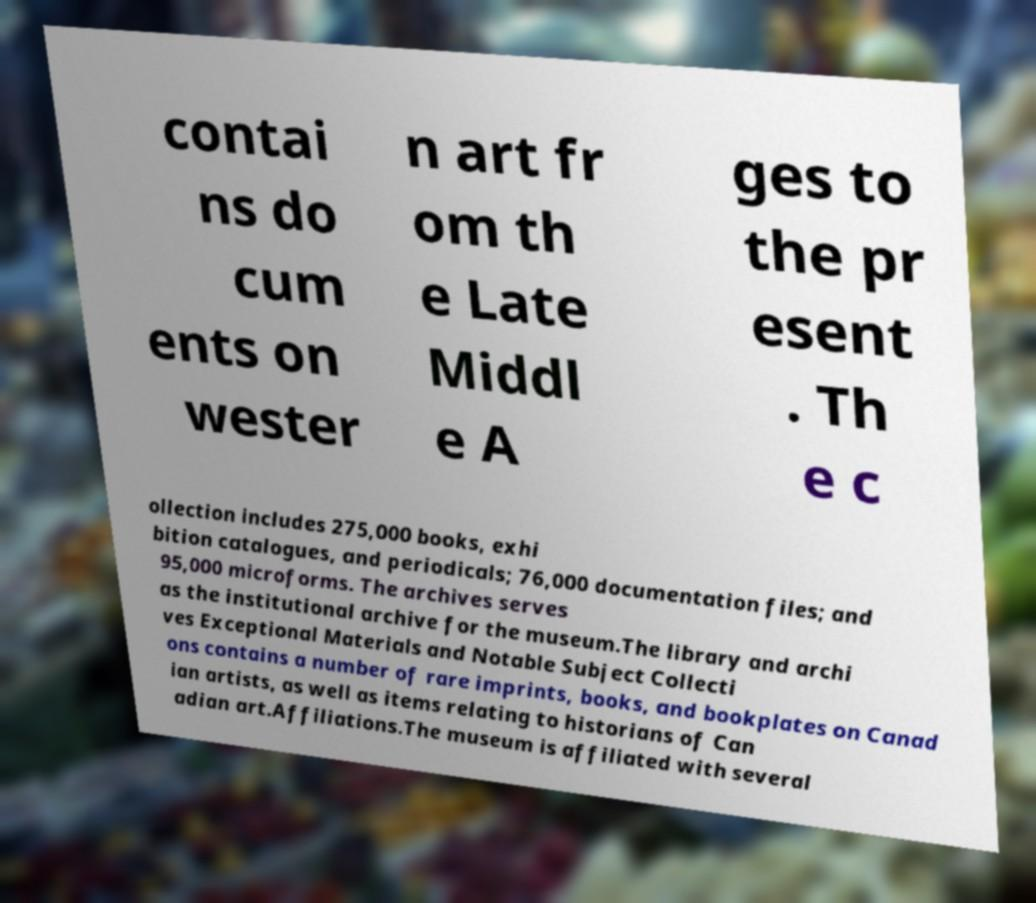For documentation purposes, I need the text within this image transcribed. Could you provide that? contai ns do cum ents on wester n art fr om th e Late Middl e A ges to the pr esent . Th e c ollection includes 275,000 books, exhi bition catalogues, and periodicals; 76,000 documentation files; and 95,000 microforms. The archives serves as the institutional archive for the museum.The library and archi ves Exceptional Materials and Notable Subject Collecti ons contains a number of rare imprints, books, and bookplates on Canad ian artists, as well as items relating to historians of Can adian art.Affiliations.The museum is affiliated with several 